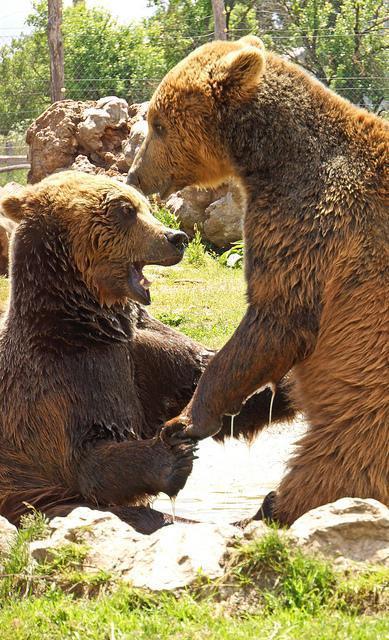How many bears do you see?
Give a very brief answer. 2. How many bears are in the picture?
Give a very brief answer. 2. How many people are wearing a white shirt?
Give a very brief answer. 0. 